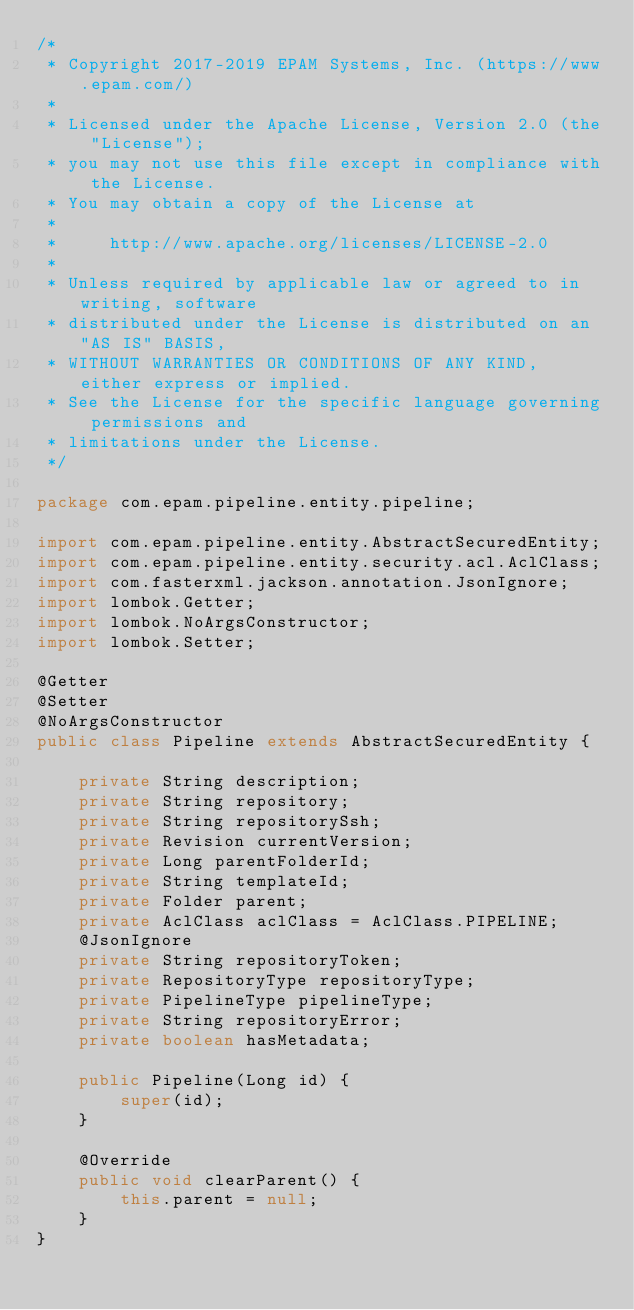<code> <loc_0><loc_0><loc_500><loc_500><_Java_>/*
 * Copyright 2017-2019 EPAM Systems, Inc. (https://www.epam.com/)
 *
 * Licensed under the Apache License, Version 2.0 (the "License");
 * you may not use this file except in compliance with the License.
 * You may obtain a copy of the License at
 *
 *     http://www.apache.org/licenses/LICENSE-2.0
 *
 * Unless required by applicable law or agreed to in writing, software
 * distributed under the License is distributed on an "AS IS" BASIS,
 * WITHOUT WARRANTIES OR CONDITIONS OF ANY KIND, either express or implied.
 * See the License for the specific language governing permissions and
 * limitations under the License.
 */

package com.epam.pipeline.entity.pipeline;

import com.epam.pipeline.entity.AbstractSecuredEntity;
import com.epam.pipeline.entity.security.acl.AclClass;
import com.fasterxml.jackson.annotation.JsonIgnore;
import lombok.Getter;
import lombok.NoArgsConstructor;
import lombok.Setter;

@Getter
@Setter
@NoArgsConstructor
public class Pipeline extends AbstractSecuredEntity {

    private String description;
    private String repository;
    private String repositorySsh;
    private Revision currentVersion;
    private Long parentFolderId;
    private String templateId;
    private Folder parent;
    private AclClass aclClass = AclClass.PIPELINE;
    @JsonIgnore
    private String repositoryToken;
    private RepositoryType repositoryType;
    private PipelineType pipelineType;
    private String repositoryError;
    private boolean hasMetadata;

    public Pipeline(Long id) {
        super(id);
    }

    @Override
    public void clearParent() {
        this.parent = null;
    }
}
</code> 